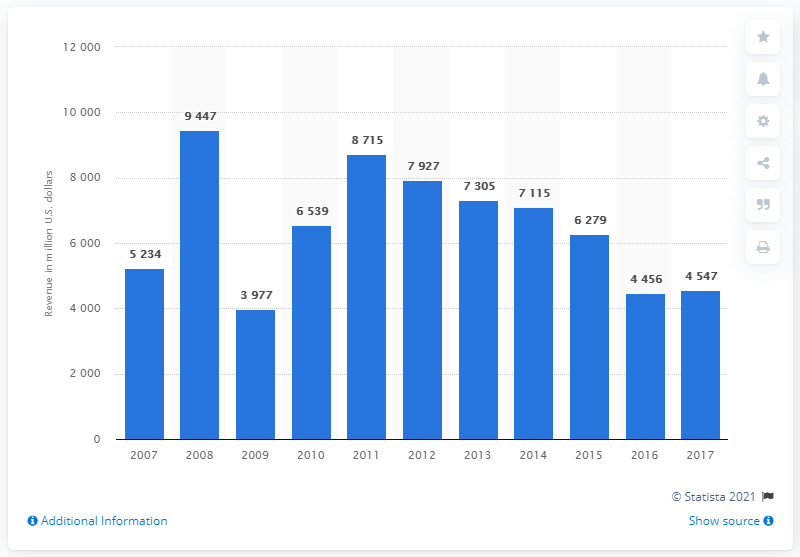Draw attention to some important aspects in this diagram. PotashCorp reported revenue of $445.6 million in 2017. 